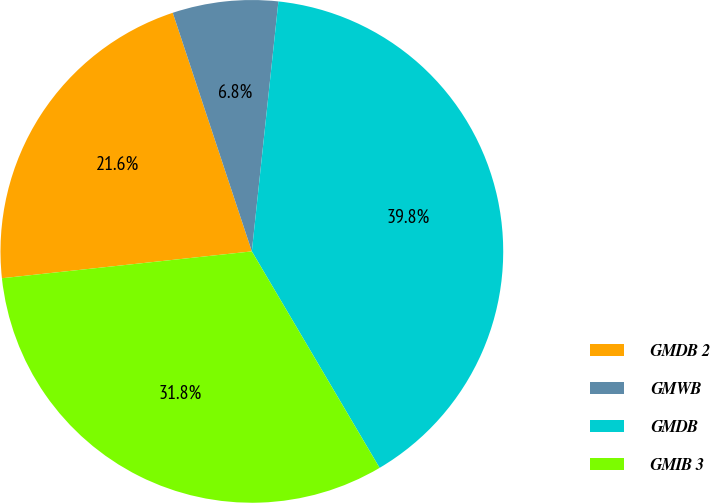<chart> <loc_0><loc_0><loc_500><loc_500><pie_chart><fcel>GMDB 2<fcel>GMWB<fcel>GMDB<fcel>GMIB 3<nl><fcel>21.61%<fcel>6.78%<fcel>39.83%<fcel>31.78%<nl></chart> 